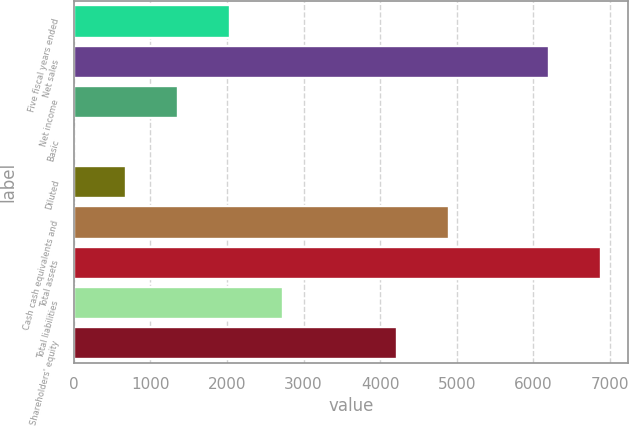Convert chart. <chart><loc_0><loc_0><loc_500><loc_500><bar_chart><fcel>Five fiscal years ended<fcel>Net sales<fcel>Net income<fcel>Basic<fcel>Diluted<fcel>Cash cash equivalents and<fcel>Total assets<fcel>Total liabilities<fcel>Shareholders' equity<nl><fcel>2045.15<fcel>6207<fcel>1363.46<fcel>0.08<fcel>681.77<fcel>4904.69<fcel>6888.69<fcel>2726.84<fcel>4223<nl></chart> 